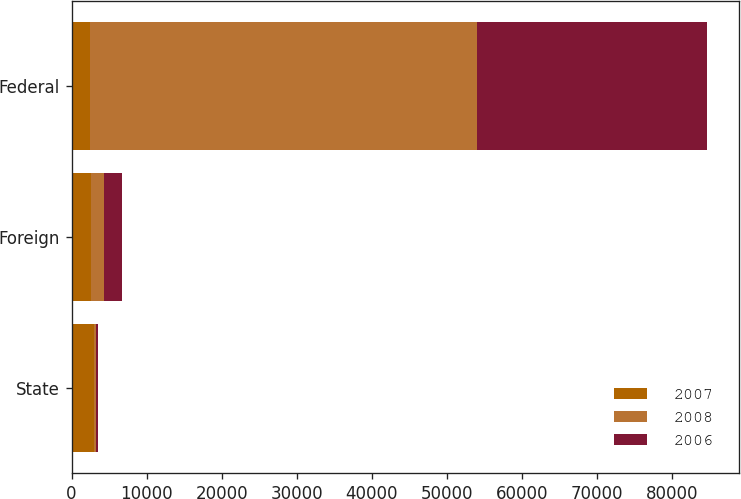<chart> <loc_0><loc_0><loc_500><loc_500><stacked_bar_chart><ecel><fcel>State<fcel>Foreign<fcel>Federal<nl><fcel>2007<fcel>2974<fcel>2626<fcel>2504.5<nl><fcel>2008<fcel>292<fcel>1685<fcel>51567<nl><fcel>2006<fcel>203<fcel>2383<fcel>30624<nl></chart> 